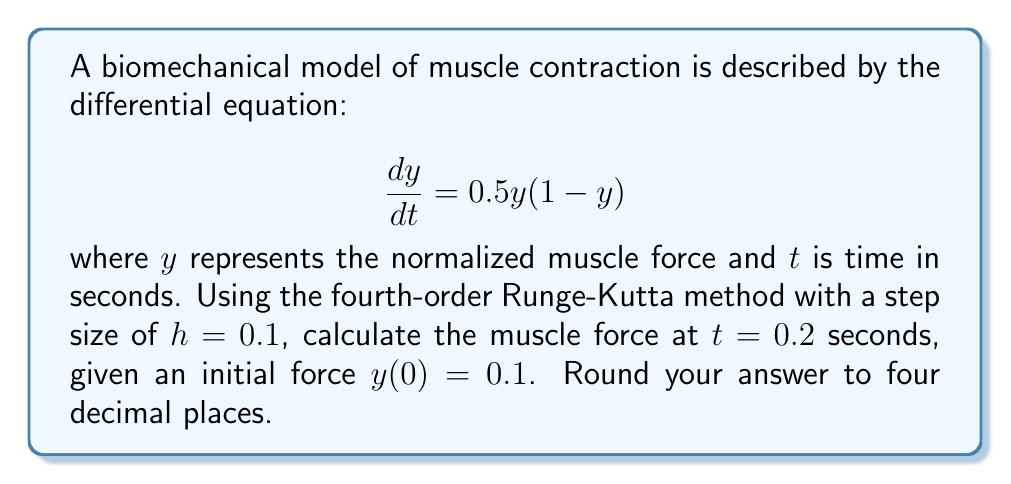Can you answer this question? Let's apply the fourth-order Runge-Kutta method to solve this problem:

1) The general form of the fourth-order Runge-Kutta method is:

   $y_{n+1} = y_n + \frac{1}{6}(k_1 + 2k_2 + 2k_3 + k_4)$

   where:
   $k_1 = hf(t_n, y_n)$
   $k_2 = hf(t_n + \frac{h}{2}, y_n + \frac{k_1}{2})$
   $k_3 = hf(t_n + \frac{h}{2}, y_n + \frac{k_2}{2})$
   $k_4 = hf(t_n + h, y_n + k_3)$

2) In our case, $f(t,y) = 0.5y(1-y)$, $h=0.1$, and $y_0 = 0.1$

3) We need to perform two iterations to reach $t=0.2$:

   Iteration 1 (from $t=0$ to $t=0.1$):
   $k_1 = 0.1 \cdot 0.5 \cdot 0.1 \cdot (1-0.1) = 0.00450$
   $k_2 = 0.1 \cdot 0.5 \cdot (0.1 + 0.00225) \cdot (1-(0.1 + 0.00225)) = 0.00456$
   $k_3 = 0.1 \cdot 0.5 \cdot (0.1 + 0.00228) \cdot (1-(0.1 + 0.00228)) = 0.00456$
   $k_4 = 0.1 \cdot 0.5 \cdot (0.1 + 0.00456) \cdot (1-(0.1 + 0.00456)) = 0.00462$

   $y_1 = 0.1 + \frac{1}{6}(0.00450 + 2(0.00456) + 2(0.00456) + 0.00462) = 0.10456$

   Iteration 2 (from $t=0.1$ to $t=0.2$):
   $k_1 = 0.1 \cdot 0.5 \cdot 0.10456 \cdot (1-0.10456) = 0.00468$
   $k_2 = 0.1 \cdot 0.5 \cdot (0.10456 + 0.00234) \cdot (1-(0.10456 + 0.00234)) = 0.00474$
   $k_3 = 0.1 \cdot 0.5 \cdot (0.10456 + 0.00237) \cdot (1-(0.10456 + 0.00237)) = 0.00474$
   $k_4 = 0.1 \cdot 0.5 \cdot (0.10456 + 0.00474) \cdot (1-(0.10456 + 0.00474)) = 0.00480$

   $y_2 = 0.10456 + \frac{1}{6}(0.00468 + 2(0.00474) + 2(0.00474) + 0.00480) = 0.10930$

4) Rounding to four decimal places, we get 0.1093.
Answer: 0.1093 